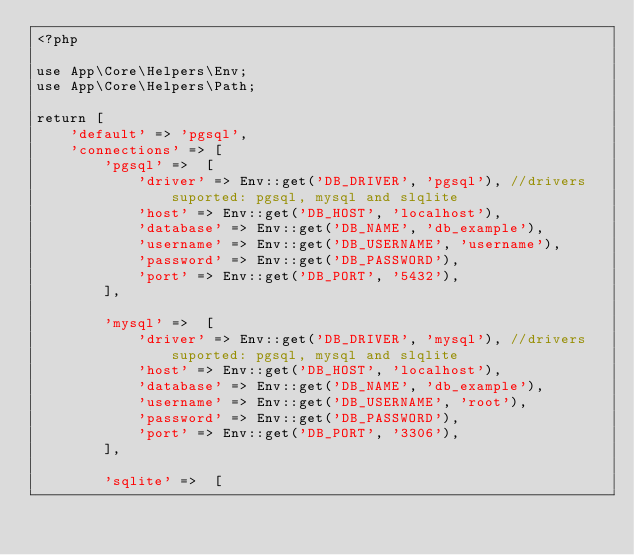<code> <loc_0><loc_0><loc_500><loc_500><_PHP_><?php

use App\Core\Helpers\Env;
use App\Core\Helpers\Path;

return [
    'default' => 'pgsql',
    'connections' => [
        'pgsql' =>  [
            'driver' => Env::get('DB_DRIVER', 'pgsql'), //drivers suported: pgsql, mysql and slqlite
            'host' => Env::get('DB_HOST', 'localhost'),
            'database' => Env::get('DB_NAME', 'db_example'),
            'username' => Env::get('DB_USERNAME', 'username'),
            'password' => Env::get('DB_PASSWORD'),
            'port' => Env::get('DB_PORT', '5432'),
        ],
        
        'mysql' =>  [
            'driver' => Env::get('DB_DRIVER', 'mysql'), //drivers suported: pgsql, mysql and slqlite
            'host' => Env::get('DB_HOST', 'localhost'),
            'database' => Env::get('DB_NAME', 'db_example'),
            'username' => Env::get('DB_USERNAME', 'root'),
            'password' => Env::get('DB_PASSWORD'),
            'port' => Env::get('DB_PORT', '3306'),
        ],

        'sqlite' =>  [</code> 